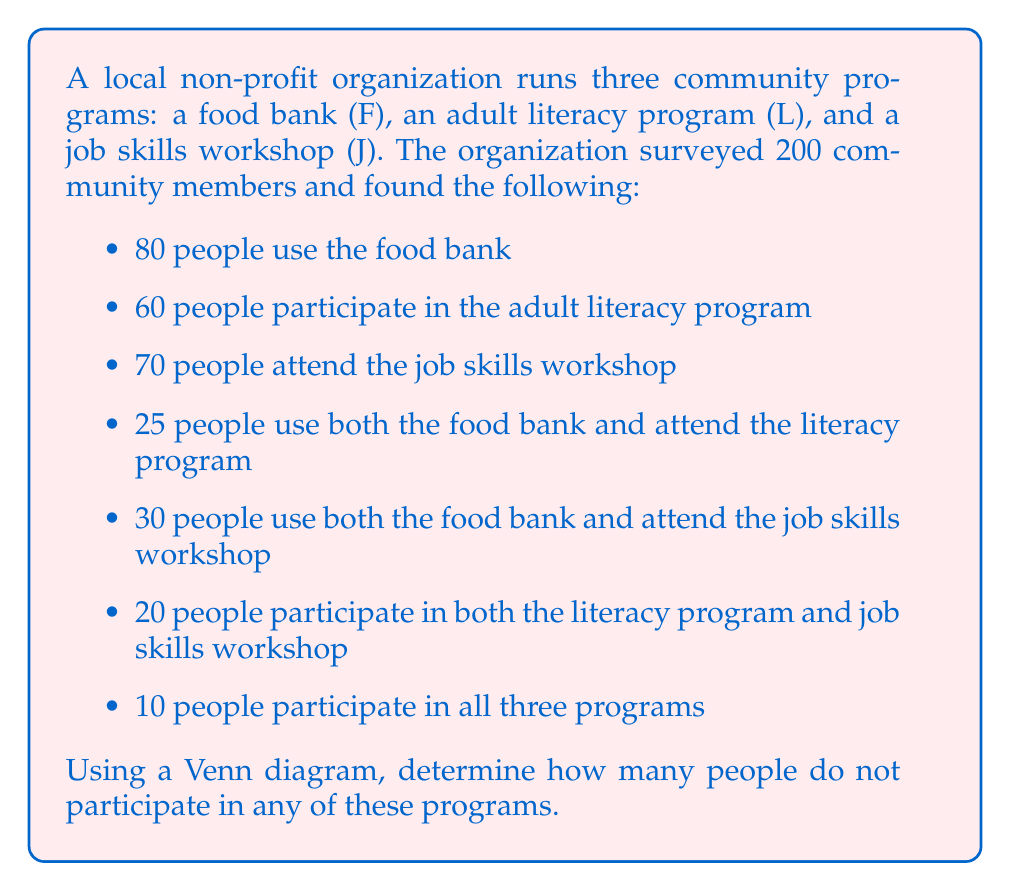Teach me how to tackle this problem. Let's approach this step-by-step using a Venn diagram:

1. First, let's draw a Venn diagram with three overlapping circles representing F, L, and J.

2. We'll fill in the known values:
   - The center (intersection of all three sets): 10
   - F ∩ L (not including J): 25 - 10 = 15
   - F ∩ J (not including L): 30 - 10 = 20
   - L ∩ J (not including F): 20 - 10 = 10

3. Now we can calculate the unique members of each set:
   - F only: 80 - (15 + 20 + 10) = 35
   - L only: 60 - (15 + 10 + 10) = 25
   - J only: 70 - (20 + 10 + 10) = 30

4. Let's add up all the numbers in our Venn diagram:
   $$ 10 + 15 + 20 + 10 + 35 + 25 + 30 = 145 $$

5. The total number of people surveyed was 200. To find how many are not in any program, we subtract:
   $$ 200 - 145 = 55 $$

Therefore, 55 people do not participate in any of these programs.

[asy]
unitsize(1cm);

pair A = (0,0), B = (1.5,2.6), C = (3,0);
real r = 1.5;

path c1 = circle(A,r);
path c2 = circle(B,r);
path c3 = circle(C,r);

fill(c1,rgb(1,0.7,0.7));
fill(c2,rgb(0.7,1,0.7));
fill(c3,rgb(0.7,0.7,1));

draw(c1);
draw(c2);
draw(c3);

label("F", A + (-1.2,-0.2));
label("L", B + (0,1));
label("J", C + (1.2,-0.2));

label("35", A + (-0.5,0));
label("25", B + (0,0.5));
label("30", C + (0.5,0));

label("15", (A+B)/2 + (-0.2,0.2));
label("20", (A+C)/2 + (0.2,-0.2));
label("10", (B+C)/2 + (0.2,0.2));

label("10", (A+B+C)/3);

[/asy]
Answer: 55 people do not participate in any of the three programs. 